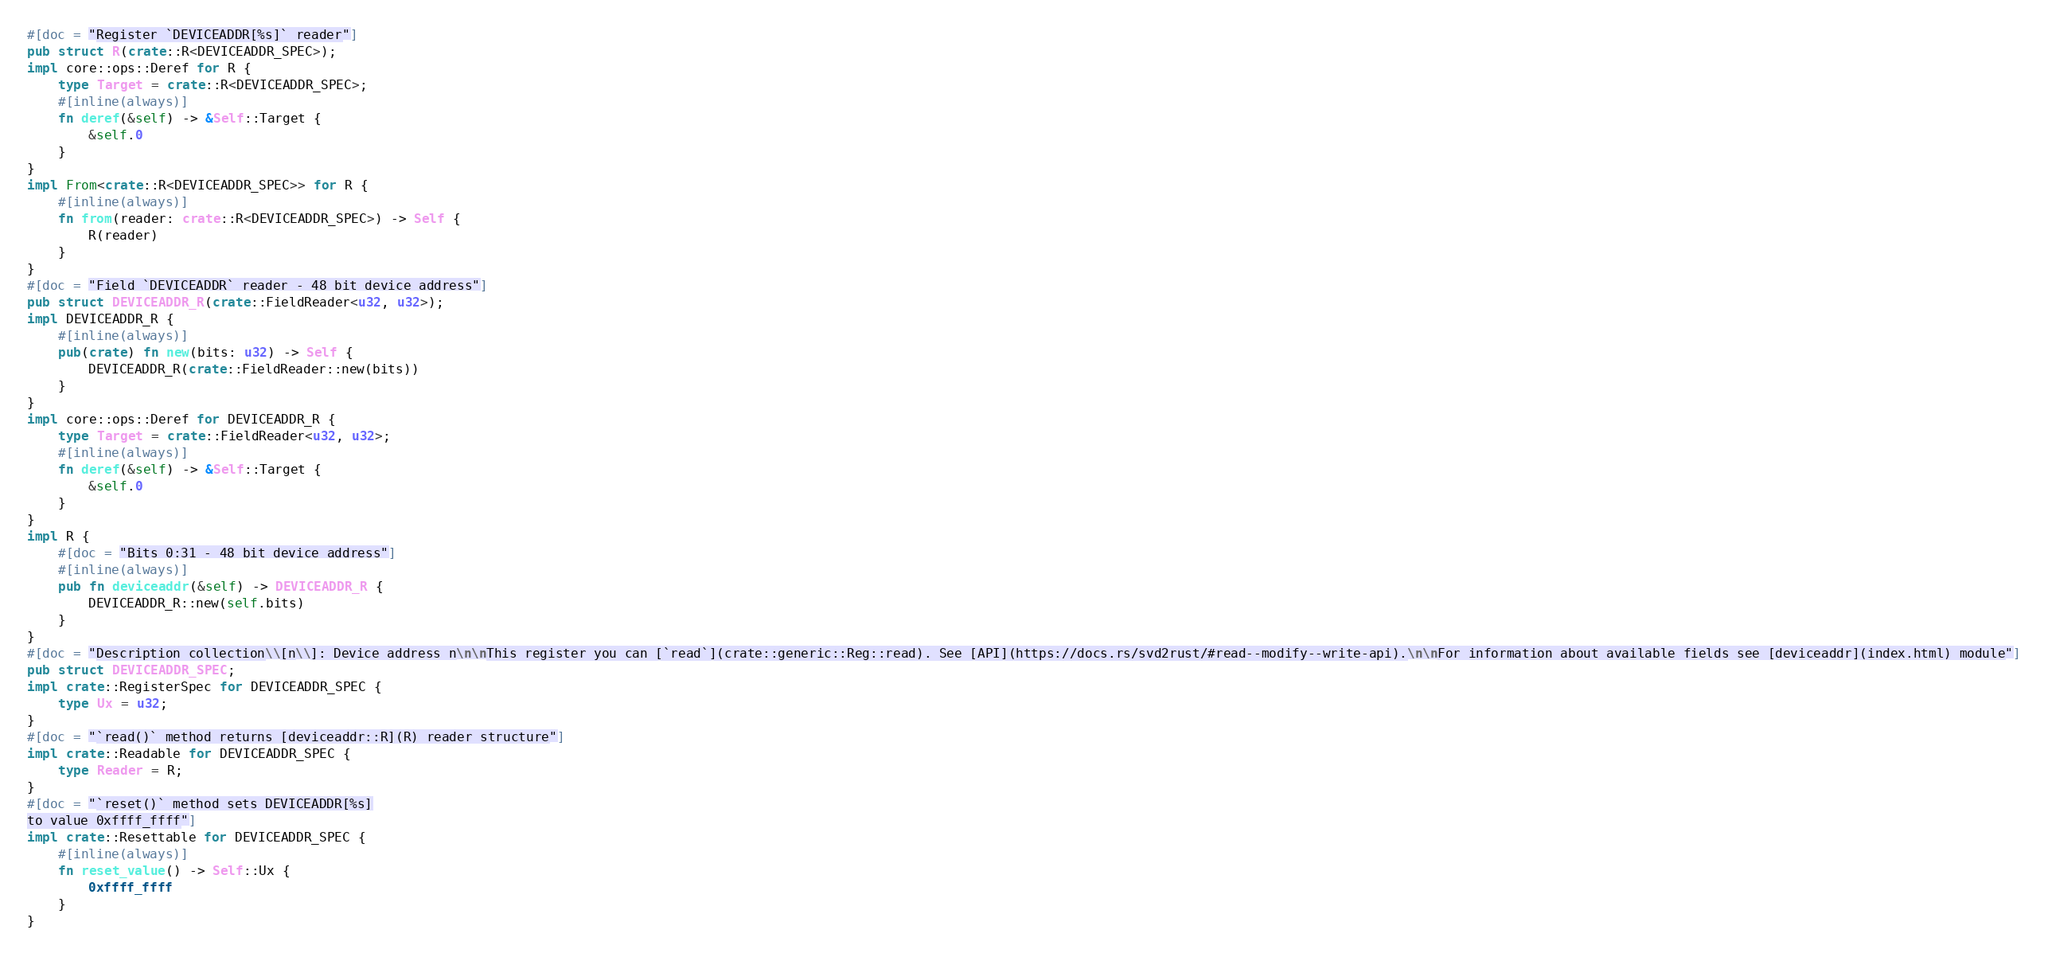<code> <loc_0><loc_0><loc_500><loc_500><_Rust_>#[doc = "Register `DEVICEADDR[%s]` reader"]
pub struct R(crate::R<DEVICEADDR_SPEC>);
impl core::ops::Deref for R {
    type Target = crate::R<DEVICEADDR_SPEC>;
    #[inline(always)]
    fn deref(&self) -> &Self::Target {
        &self.0
    }
}
impl From<crate::R<DEVICEADDR_SPEC>> for R {
    #[inline(always)]
    fn from(reader: crate::R<DEVICEADDR_SPEC>) -> Self {
        R(reader)
    }
}
#[doc = "Field `DEVICEADDR` reader - 48 bit device address"]
pub struct DEVICEADDR_R(crate::FieldReader<u32, u32>);
impl DEVICEADDR_R {
    #[inline(always)]
    pub(crate) fn new(bits: u32) -> Self {
        DEVICEADDR_R(crate::FieldReader::new(bits))
    }
}
impl core::ops::Deref for DEVICEADDR_R {
    type Target = crate::FieldReader<u32, u32>;
    #[inline(always)]
    fn deref(&self) -> &Self::Target {
        &self.0
    }
}
impl R {
    #[doc = "Bits 0:31 - 48 bit device address"]
    #[inline(always)]
    pub fn deviceaddr(&self) -> DEVICEADDR_R {
        DEVICEADDR_R::new(self.bits)
    }
}
#[doc = "Description collection\\[n\\]: Device address n\n\nThis register you can [`read`](crate::generic::Reg::read). See [API](https://docs.rs/svd2rust/#read--modify--write-api).\n\nFor information about available fields see [deviceaddr](index.html) module"]
pub struct DEVICEADDR_SPEC;
impl crate::RegisterSpec for DEVICEADDR_SPEC {
    type Ux = u32;
}
#[doc = "`read()` method returns [deviceaddr::R](R) reader structure"]
impl crate::Readable for DEVICEADDR_SPEC {
    type Reader = R;
}
#[doc = "`reset()` method sets DEVICEADDR[%s]
to value 0xffff_ffff"]
impl crate::Resettable for DEVICEADDR_SPEC {
    #[inline(always)]
    fn reset_value() -> Self::Ux {
        0xffff_ffff
    }
}
</code> 